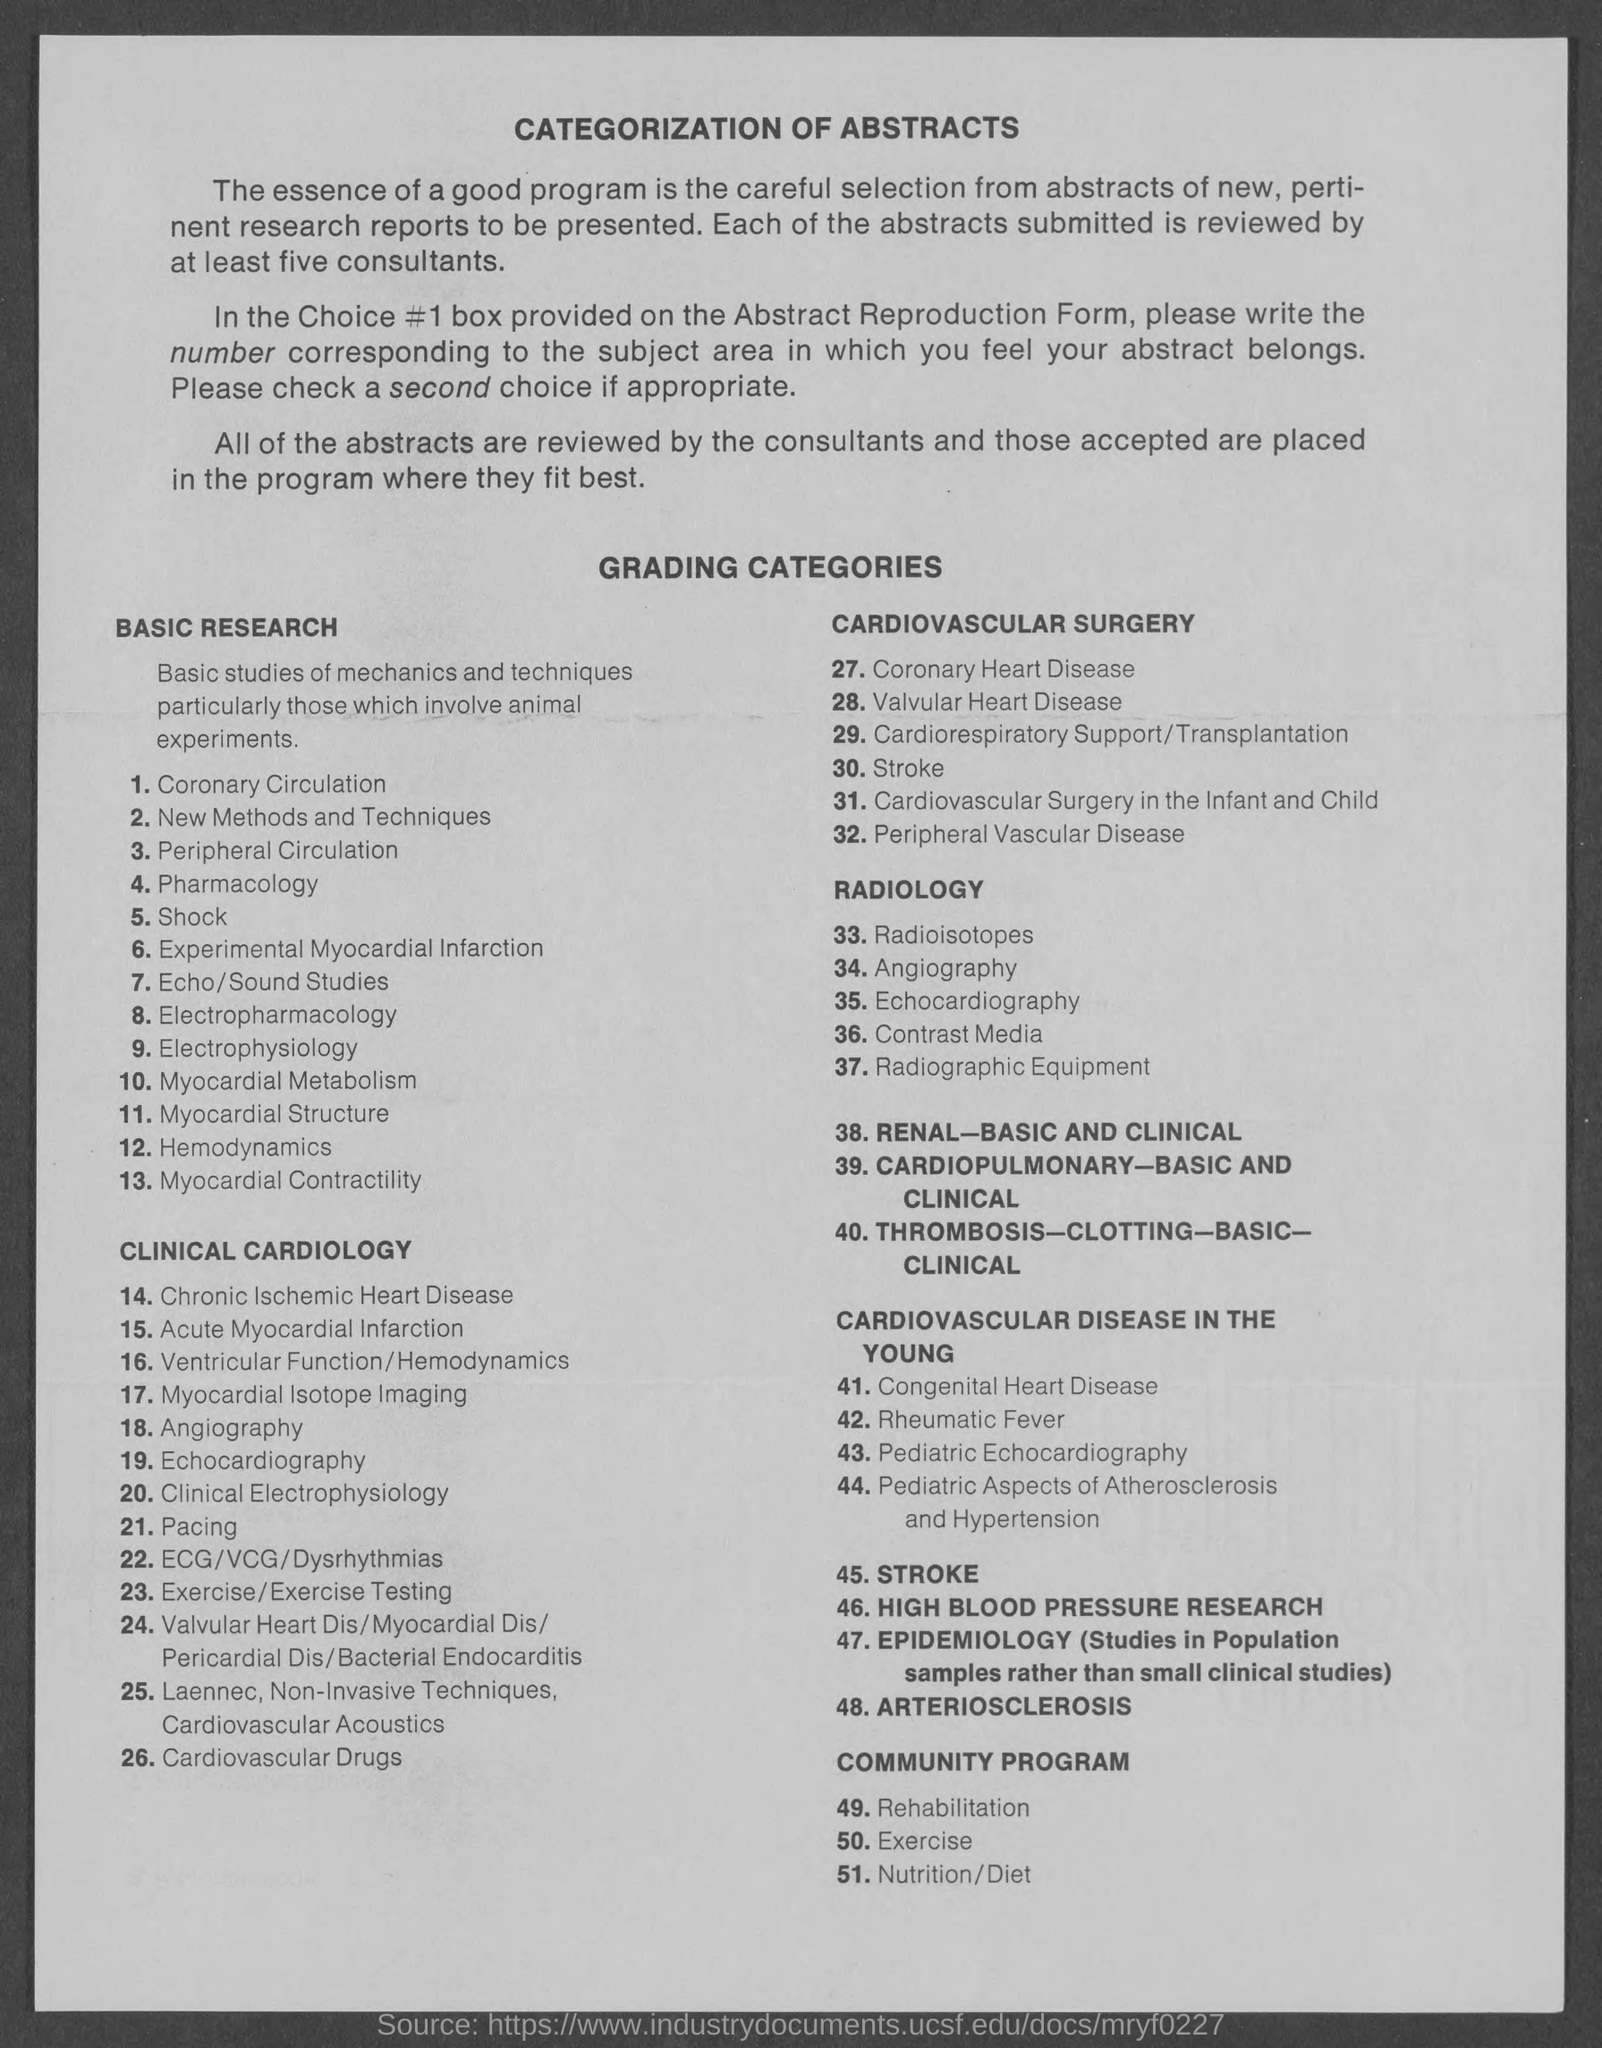Outline some significant characteristics in this image. The title of the document is "Categorization of Abstracts. The review of abstracts is conducted by the consultants. 